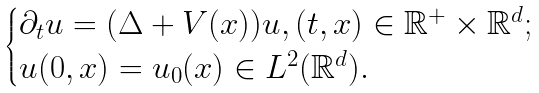Convert formula to latex. <formula><loc_0><loc_0><loc_500><loc_500>\begin{cases} \partial _ { t } u = ( \Delta + V ( x ) ) u , ( t , x ) \in \mathbb { R } ^ { + } \times \mathbb { R } ^ { d } ; \\ u ( 0 , x ) = u _ { 0 } ( x ) \in L ^ { 2 } ( \mathbb { R } ^ { d } ) . \end{cases}</formula> 